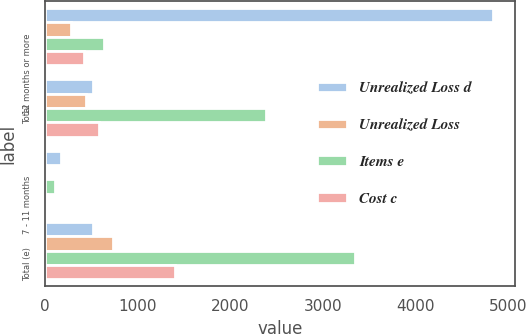Convert chart. <chart><loc_0><loc_0><loc_500><loc_500><stacked_bar_chart><ecel><fcel>12 months or more<fcel>Total<fcel>7 - 11 months<fcel>Total (e)<nl><fcel>Unrealized Loss d<fcel>4830<fcel>513.5<fcel>175<fcel>513.5<nl><fcel>Unrealized Loss<fcel>277<fcel>444<fcel>9<fcel>736<nl><fcel>Items e<fcel>631<fcel>2380<fcel>108<fcel>3350<nl><fcel>Cost c<fcel>416<fcel>583<fcel>15<fcel>1396<nl></chart> 